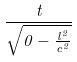<formula> <loc_0><loc_0><loc_500><loc_500>\frac { t } { \sqrt { 0 - \frac { l ^ { 2 } } { c ^ { 2 } } } }</formula> 